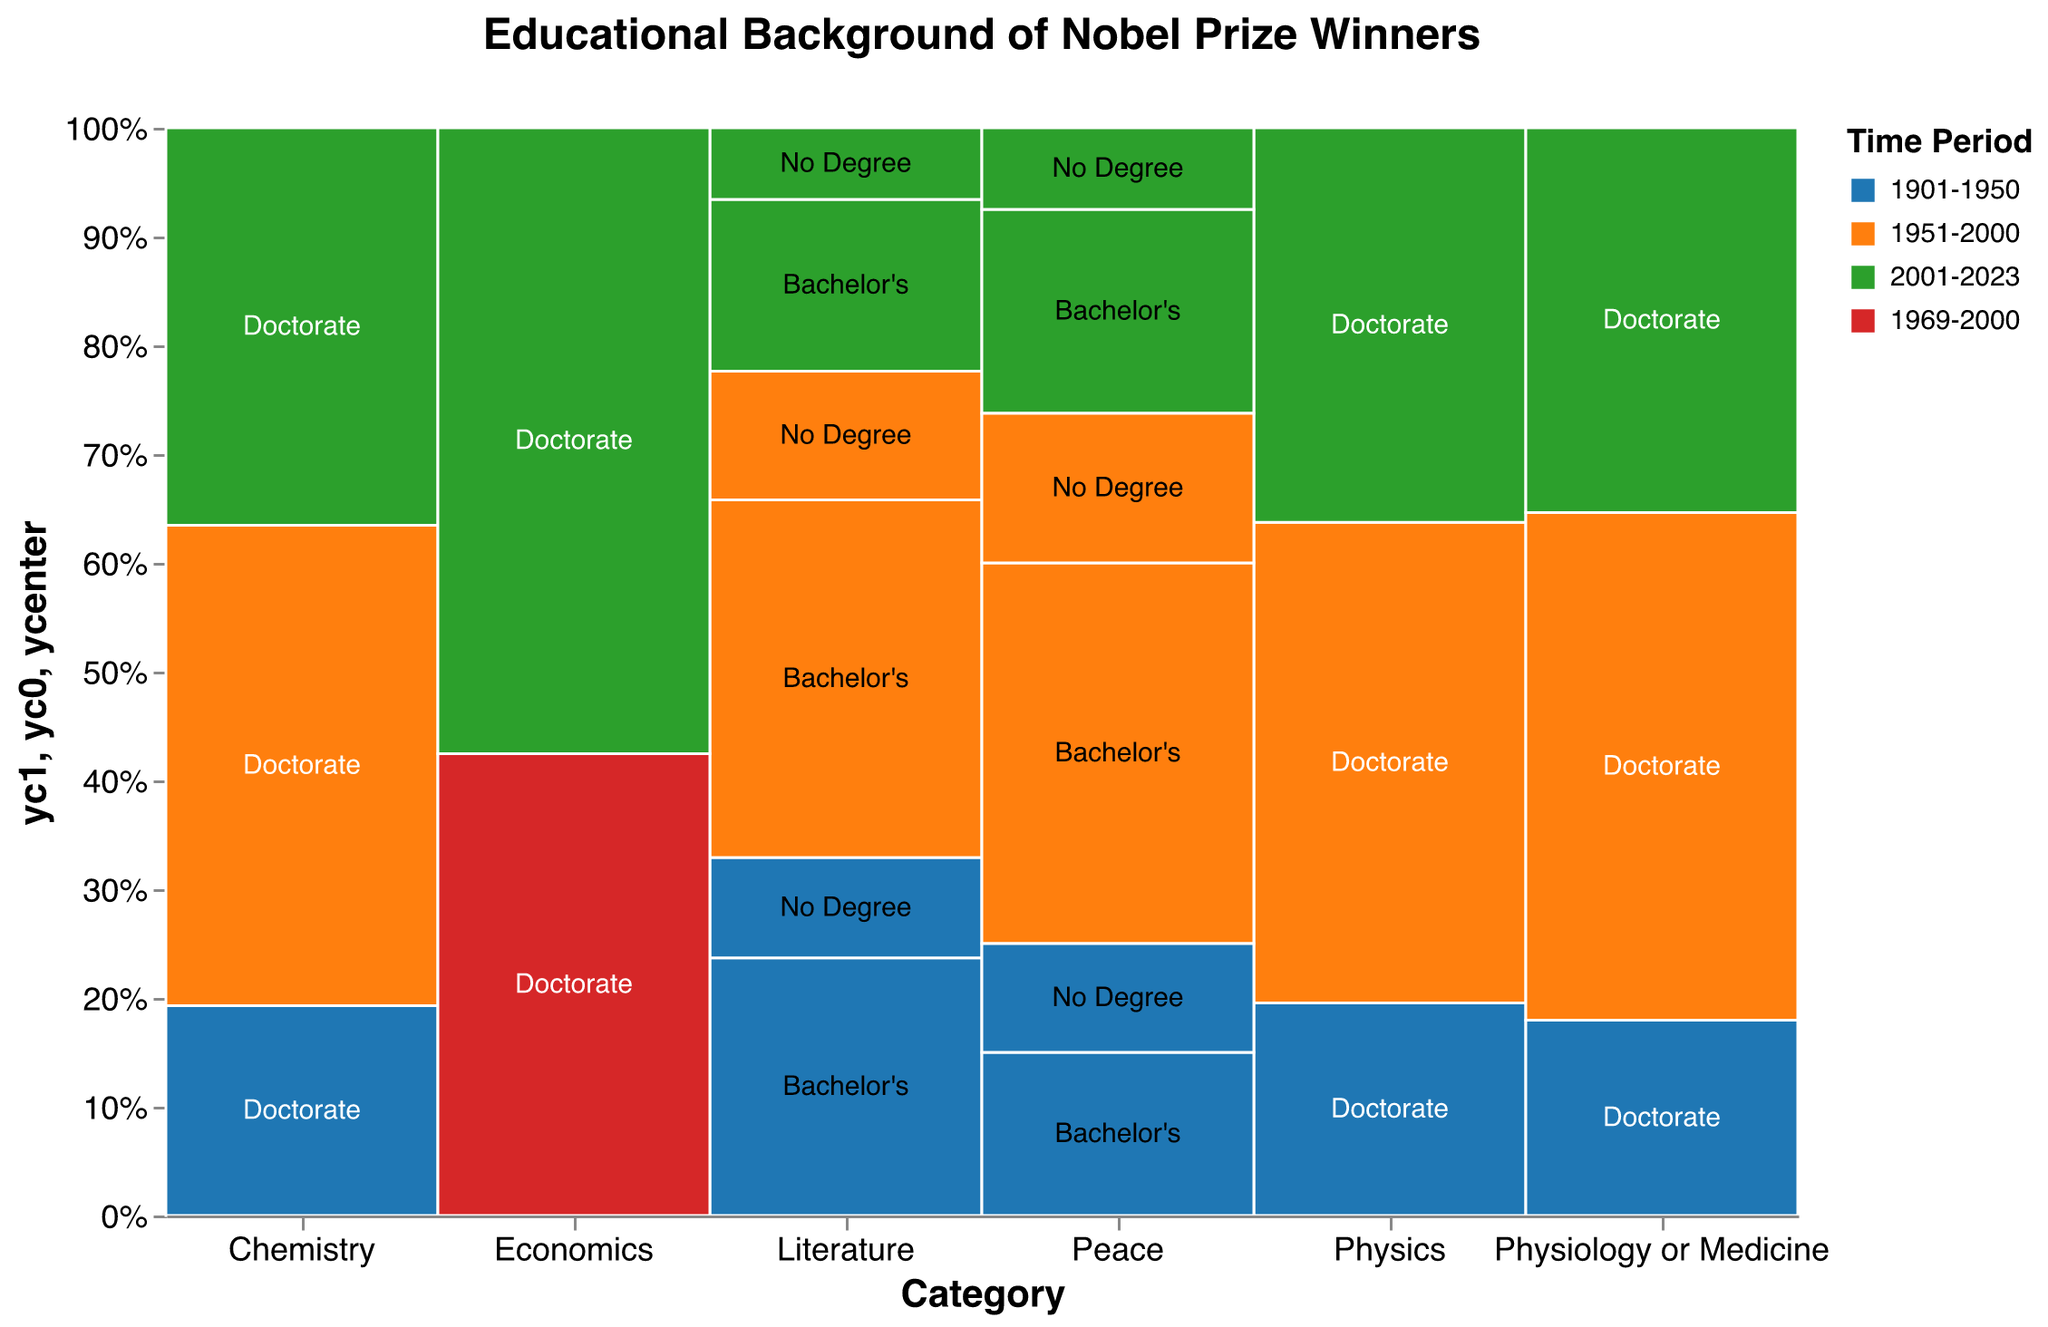What is the title of the plot? The title of the plot is displayed at the top and reads "Educational Background of Nobel Prize Winners".
Answer: Educational Background of Nobel Prize Winners Which time period sees the greatest number of Nobel Prize winners with a Doctorate in Physics? Observe the color and size of the bar for each time period in the Physics category. The time period 1951-2000, represented by the orange color, has the largest section indicating the highest count.
Answer: 1951-2000 How many Nobel Prize winners in Literature from 2001-2023 had no degree? Look for the Literature category, locate the section from 2001-2023, which is in green color, and find the part labeled "No Degree". The count annotation should reflect 5.
Answer: 5 Compare the number of Nobel Prize winners with Doctorates in Chemistry between 1951-2000 and 2001-2023. Look at the Chemistry category for both 1951-2000 (orange) and 2001-2023 (green). The counts are 87 for 1951-2000 and 72 for 2001-2023. Subtract these values: 87 - 72 = 15
Answer: 15 In which category and time period combinations are Bachelor’s degrees most predominant? Identify the sections with labels for Bachelor's degrees and compare them across categories and time periods. Literature and Peace sections for 1951-2000 (orange) and 2001-2023 (green) prominently show Bachelor's degrees. Peace in 1951-2000 stands out more noticeably.
Answer: Peace, 1951-2000 What proportion of Nobel Prize winners in the Economics category had Doctorates from 2001-2023 compared to 1969-2000? Look at the Economics category for both time periods. Sum the counts (42 + 31) to get the total, and calculate the proportion for 2001-2023 as 42/(42+31).
Answer: 42/73 Is there any category where the number of Doctorate holders decreases over each consecutive time period? Check each category and evaluate the trend over the three time periods (1901-1950, 1951-2000, 2001-2023). Physiology or Medicine shows a decreasing trend from 1951-2000 (91) to 2001-2023 (69).
Answer: Yes, Physiology or Medicine Which categories have the smallest representation of Doctorates across all time periods? Observe the sections labeled "Doctorate" in each category and compare their relative sizes. Literature and Peace have noticeably smaller sections for Doctorates.
Answer: Literature and Peace How does the count of Nobel Prize winners in Peace with no degree change across the three time periods? Locate the sections in the Peace category labeled "No Degree", color-coded by time period. Compare the counts 1901-1950 (8), 1951-2000 (11), and 2001-2023 (6). Identify the changes: from 8 to 11 (increase) and from 11 to 6 (decrease).
Answer: Increase then decrease What is the most common educational level among Nobel Prize winners in the Chemistry category? Identify the sections in Chemistry labeled with various education levels. The largest sections are those labeled "Doctorate" across all time periods, indicating it is most common.
Answer: Doctorate 